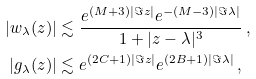<formula> <loc_0><loc_0><loc_500><loc_500>| w _ { \lambda } ( z ) | & \lesssim \frac { e ^ { ( M + 3 ) | \Im z | } e ^ { - ( M - 3 ) | \Im \lambda | } } { 1 + | z - \lambda | ^ { 3 } } \ , \\ | g _ { \lambda } ( z ) | & \lesssim e ^ { ( 2 C + 1 ) | \Im z | } e ^ { ( 2 B + 1 ) | \Im \lambda | } \ ,</formula> 